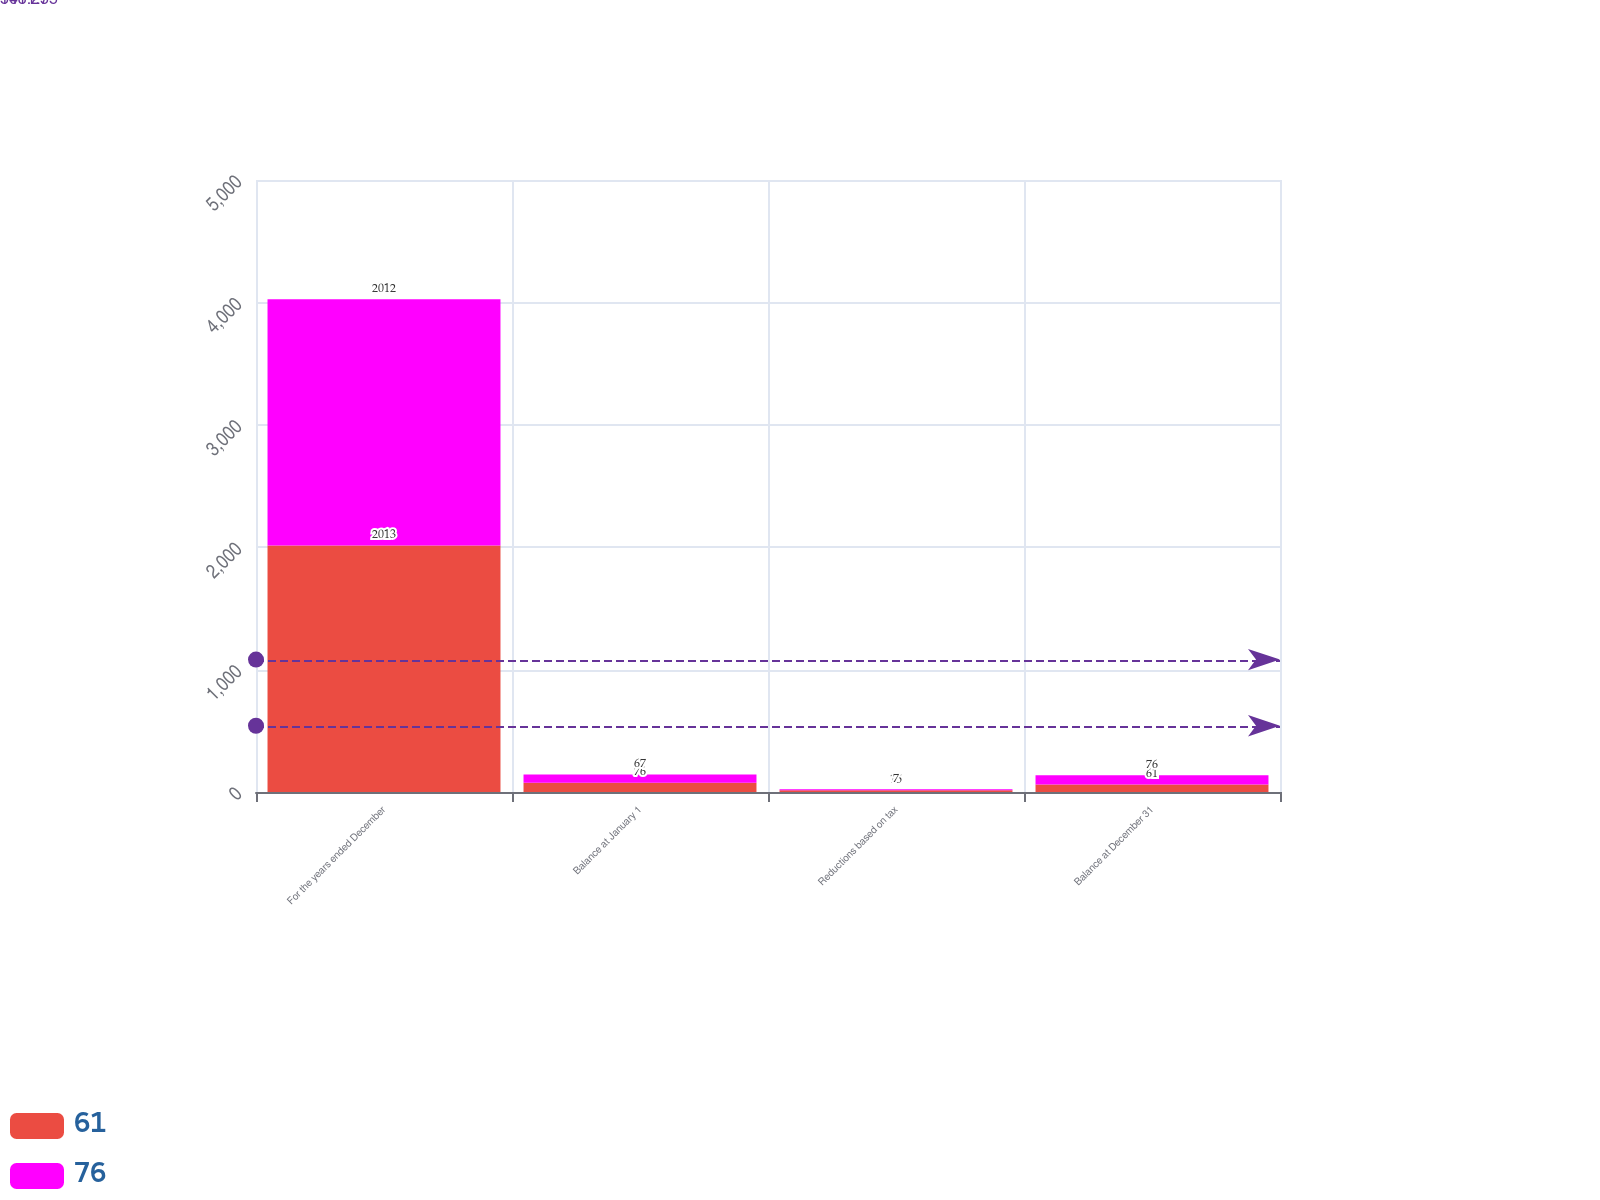<chart> <loc_0><loc_0><loc_500><loc_500><stacked_bar_chart><ecel><fcel>For the years ended December<fcel>Balance at January 1<fcel>Reductions based on tax<fcel>Balance at December 31<nl><fcel>61<fcel>2013<fcel>76<fcel>15<fcel>61<nl><fcel>76<fcel>2012<fcel>67<fcel>7<fcel>76<nl></chart> 